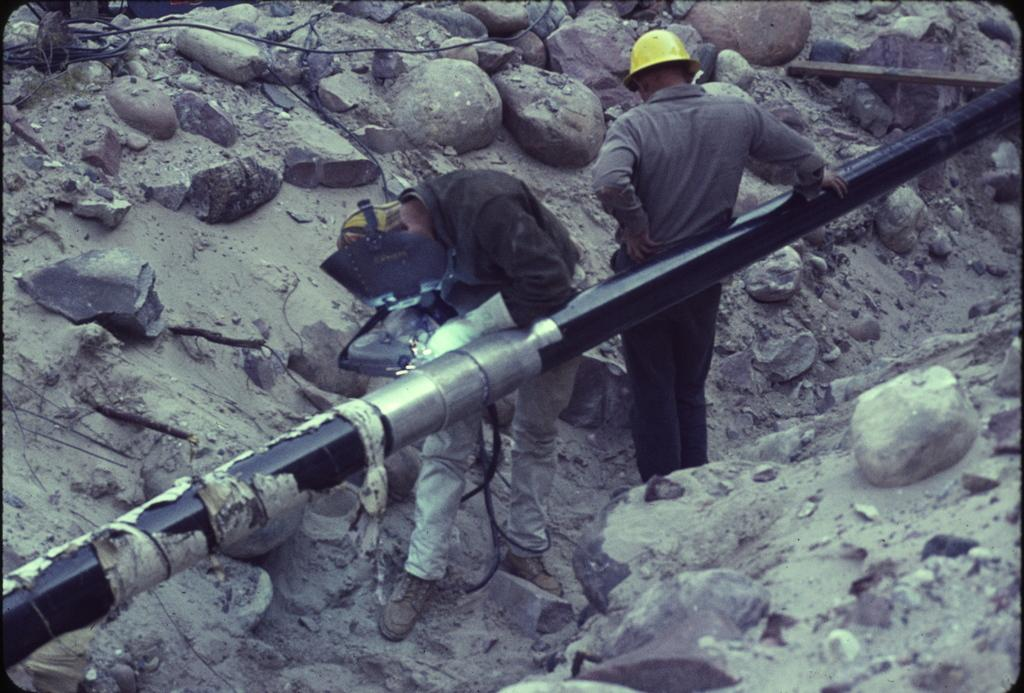What type of objects can be seen in the image? There are stones and a pipeline visible in the image. Can you describe the people in the image? There are two persons visible in the image. What type of seed is being planted by the persons in the image? There is no seed or planting activity depicted in the image; it only shows stones and a pipeline. 